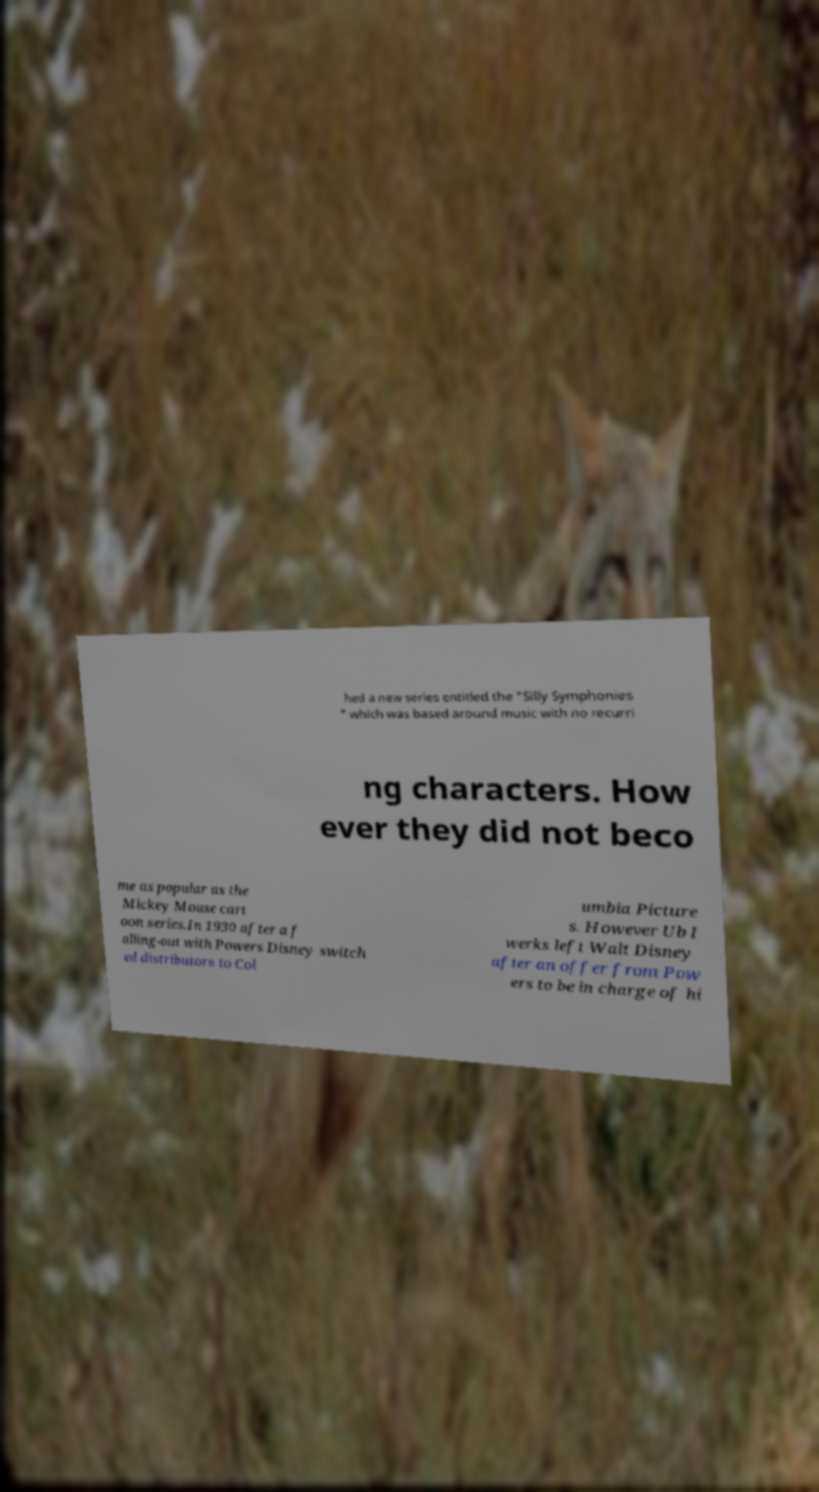Could you extract and type out the text from this image? hed a new series entitled the "Silly Symphonies " which was based around music with no recurri ng characters. How ever they did not beco me as popular as the Mickey Mouse cart oon series.In 1930 after a f alling-out with Powers Disney switch ed distributors to Col umbia Picture s. However Ub I werks left Walt Disney after an offer from Pow ers to be in charge of hi 